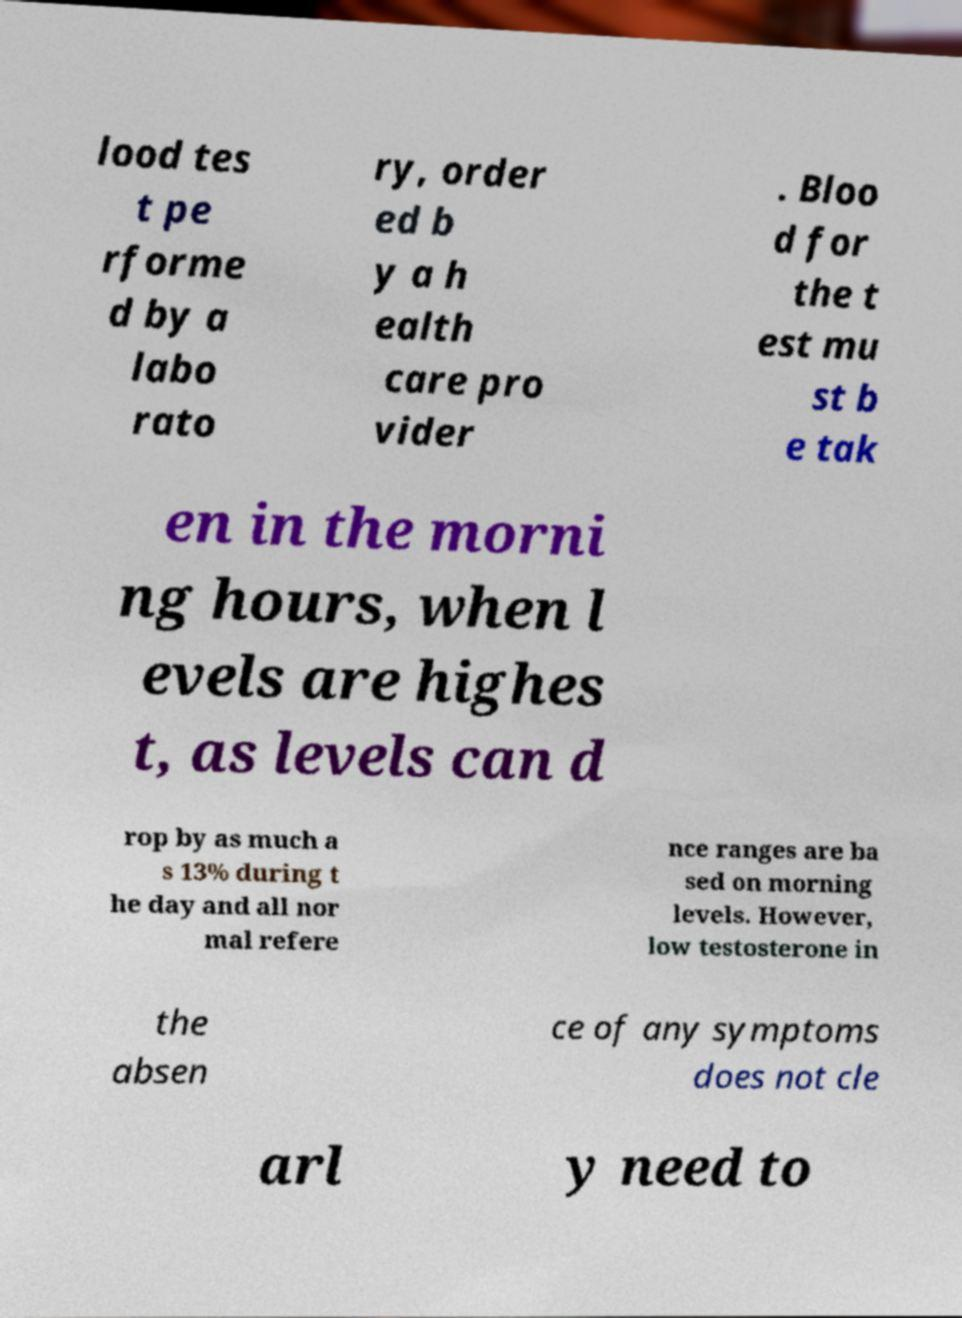Can you read and provide the text displayed in the image?This photo seems to have some interesting text. Can you extract and type it out for me? lood tes t pe rforme d by a labo rato ry, order ed b y a h ealth care pro vider . Bloo d for the t est mu st b e tak en in the morni ng hours, when l evels are highes t, as levels can d rop by as much a s 13% during t he day and all nor mal refere nce ranges are ba sed on morning levels. However, low testosterone in the absen ce of any symptoms does not cle arl y need to 